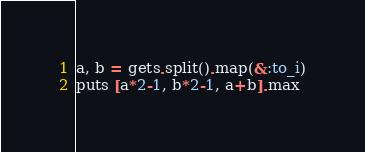Convert code to text. <code><loc_0><loc_0><loc_500><loc_500><_Ruby_>a, b = gets.split().map(&:to_i)
puts [a*2-1, b*2-1, a+b].max</code> 